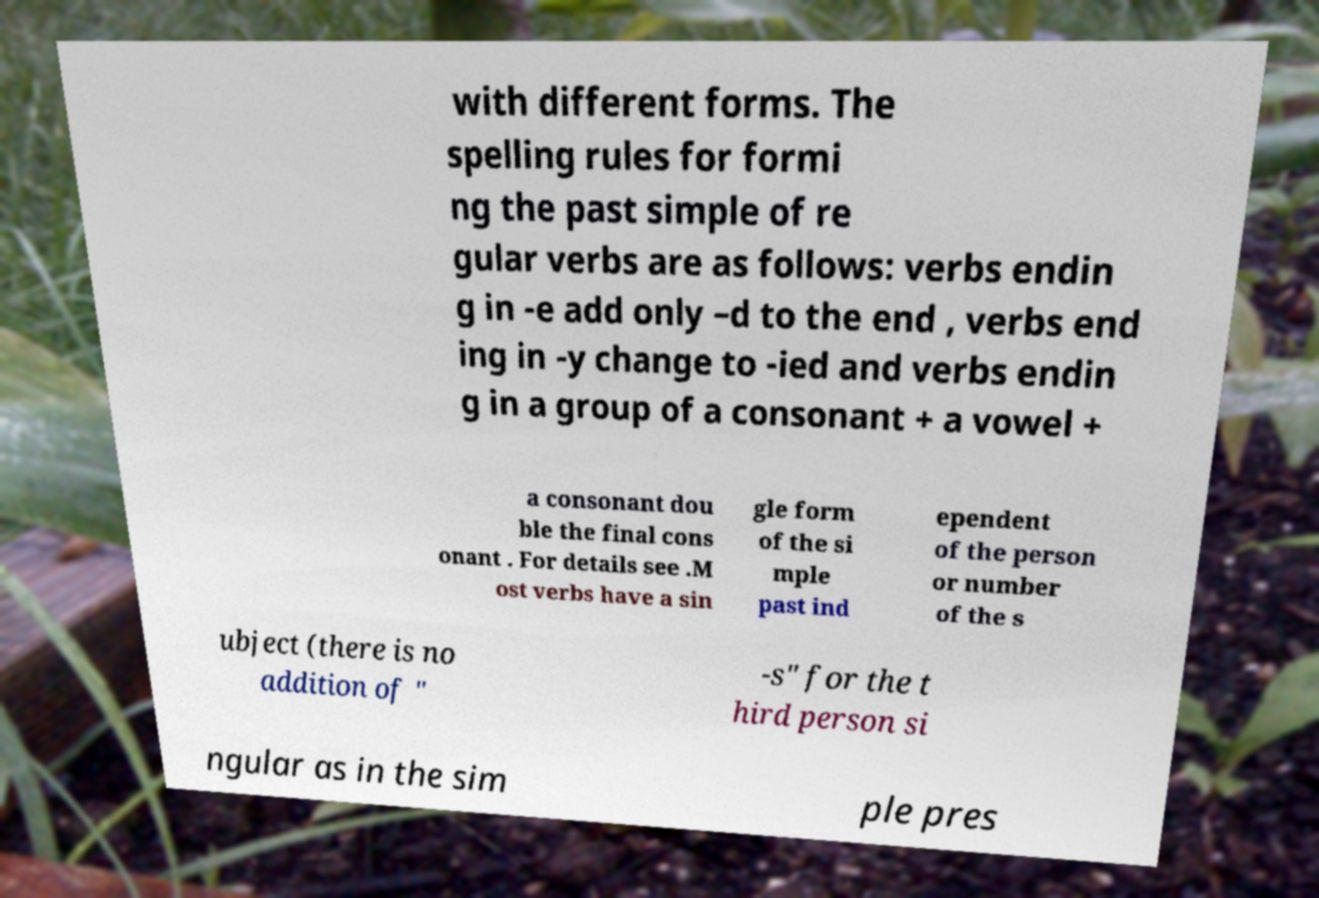Please read and relay the text visible in this image. What does it say? with different forms. The spelling rules for formi ng the past simple of re gular verbs are as follows: verbs endin g in -e add only –d to the end , verbs end ing in -y change to -ied and verbs endin g in a group of a consonant + a vowel + a consonant dou ble the final cons onant . For details see .M ost verbs have a sin gle form of the si mple past ind ependent of the person or number of the s ubject (there is no addition of " -s" for the t hird person si ngular as in the sim ple pres 